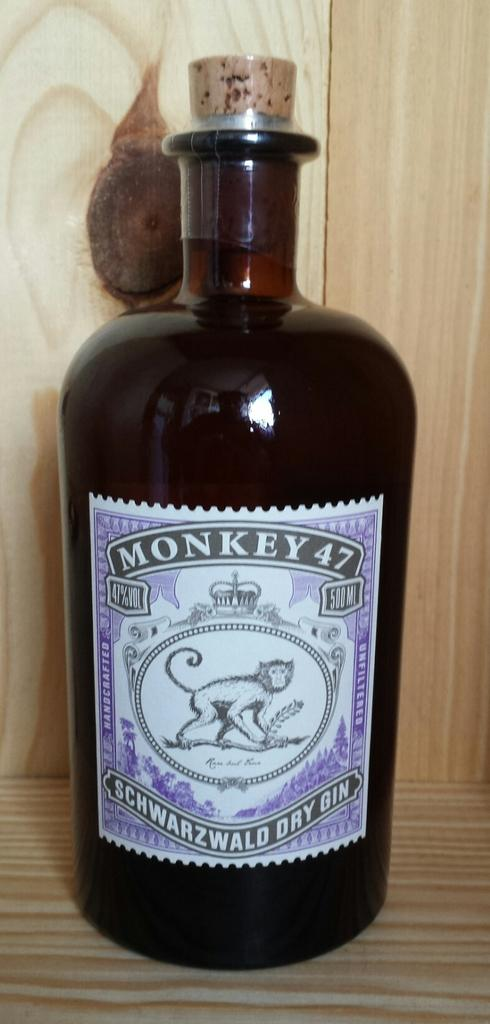<image>
Present a compact description of the photo's key features. Brown jug of Monkey 47 Schwarzwald Dry Gin 